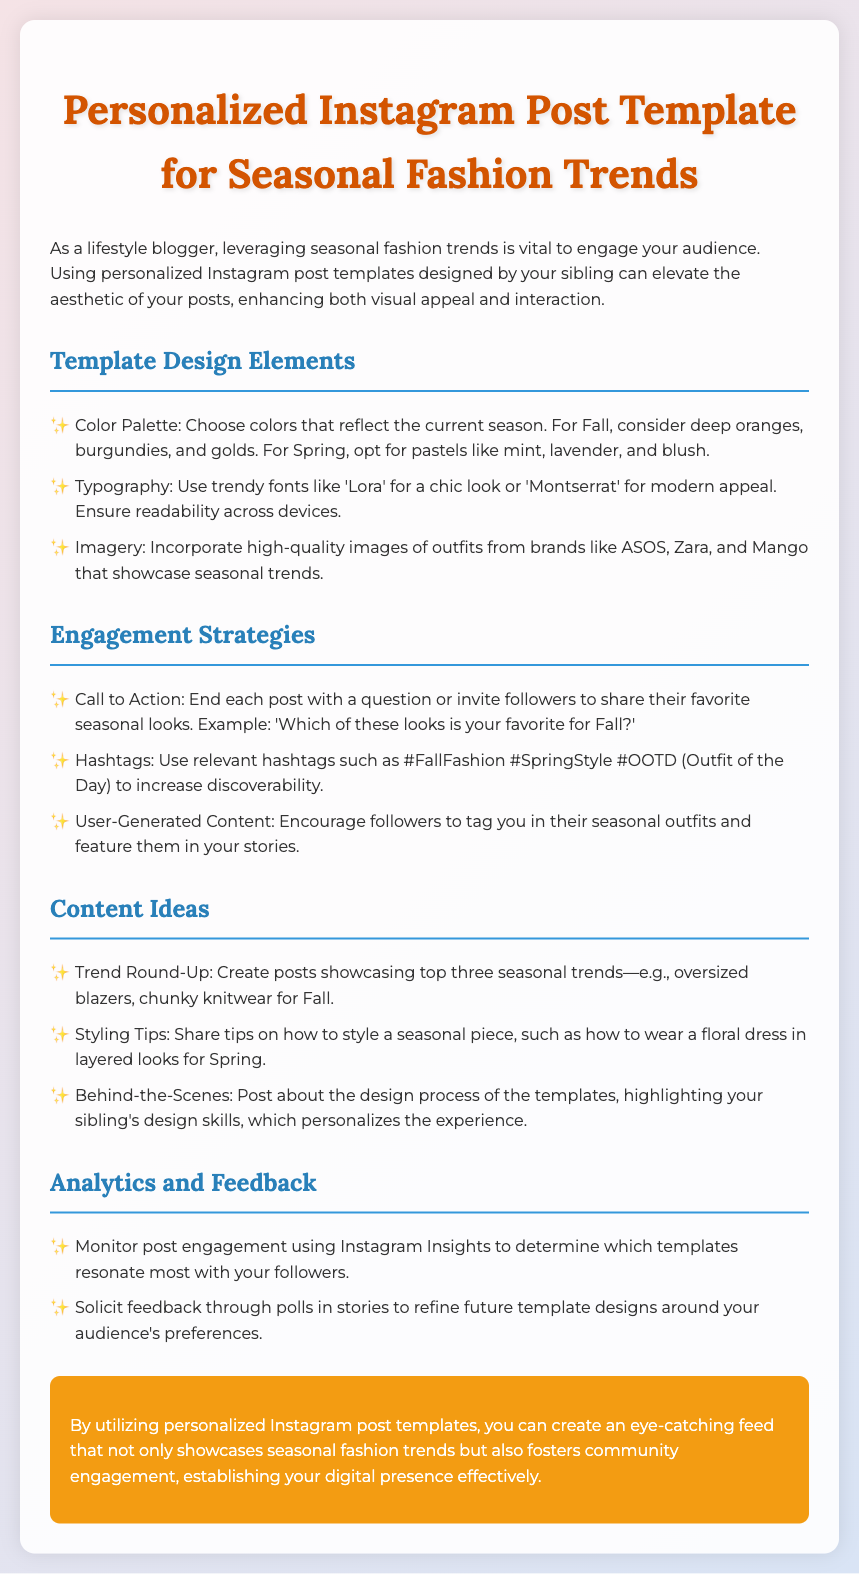What is the primary purpose of using personalized Instagram post templates? The document mentions that leveraging seasonal fashion trends is vital for audience engagement.
Answer: Engagement What color palette is suggested for Fall? The document indicates that for Fall, colors like deep oranges, burgundies, and golds are recommended.
Answer: Deep oranges, burgundies, and golds Which font is used for a chic look? The document specifies that the font 'Lora' is used for a chic look.
Answer: Lora What is one suggested call to action for posts? The document provides an example call to action, which is to ask followers which looks are their favorites.
Answer: Which of these looks is your favorite for Fall? How many seasonal trends are suggested for a trend round-up? The document states that a trend round-up should showcase the top three seasonal trends.
Answer: Three What feedback method is suggested in the document? The document suggests soliciting feedback through polls in stories.
Answer: Polls Which aspect of the templates highlights the sibling's skills? The document mentions that posts about the design process of the templates highlight your sibling's design skills.
Answer: Design process What platform is used to monitor post engagement? The document specifies that Instagram Insights is used for monitoring engagement.
Answer: Instagram Insights 